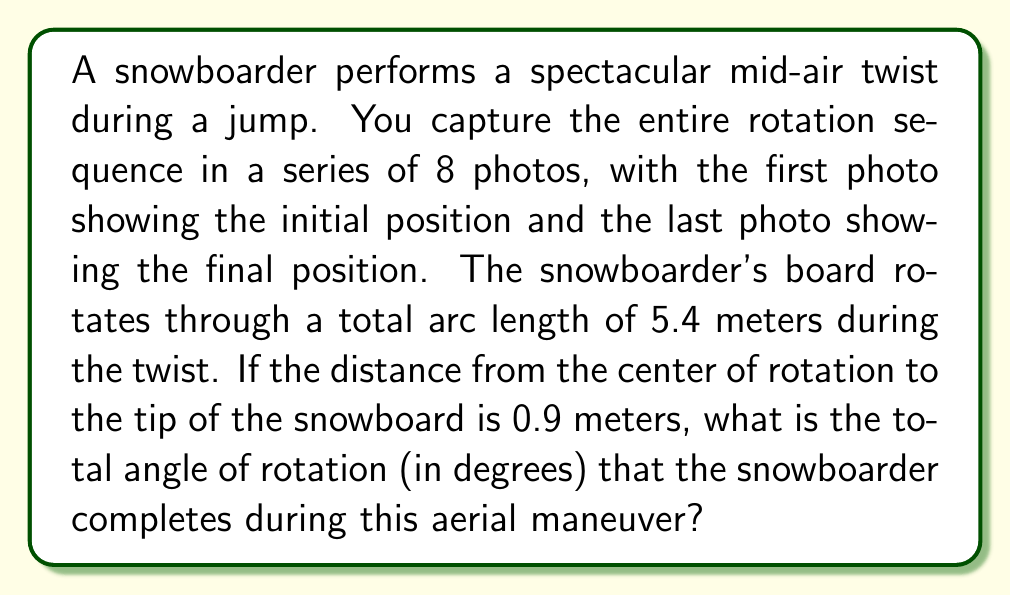What is the answer to this math problem? To solve this problem, we need to use the formula for arc length and convert radians to degrees. Let's break it down step-by-step:

1) The formula for arc length is:
   $s = r\theta$
   Where:
   $s$ = arc length
   $r$ = radius (distance from center of rotation to tip of snowboard)
   $\theta$ = angle in radians

2) We are given:
   $s = 5.4$ meters
   $r = 0.9$ meters

3) Let's substitute these values into the formula:
   $5.4 = 0.9\theta$

4) Solve for $\theta$:
   $$\theta = \frac{5.4}{0.9} = 6 \text{ radians}$$

5) Now we need to convert radians to degrees. The conversion formula is:
   $\text{degrees} = \text{radians} \times \frac{180°}{\pi}$

6) Let's substitute our value:
   $$\text{degrees} = 6 \times \frac{180°}{\pi} = \frac{1080°}{\pi} \approx 343.77°$$

Therefore, the snowboarder completes approximately 343.77° of rotation during the aerial maneuver.
Answer: The total angle of rotation is approximately 343.77°. 